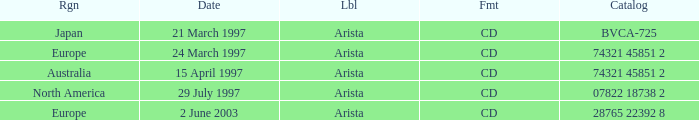What Label has the Region of Australia? Arista. 